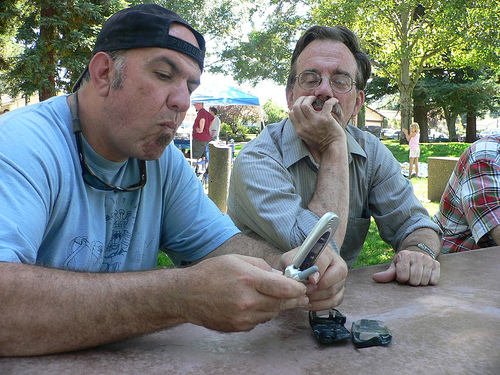<image>Who is he calling? I don't know who he is calling. It could be a friend, wife, mom, or father. Who is he calling? I don't know who he is calling. It can be his friend, wife, mom, or father. 